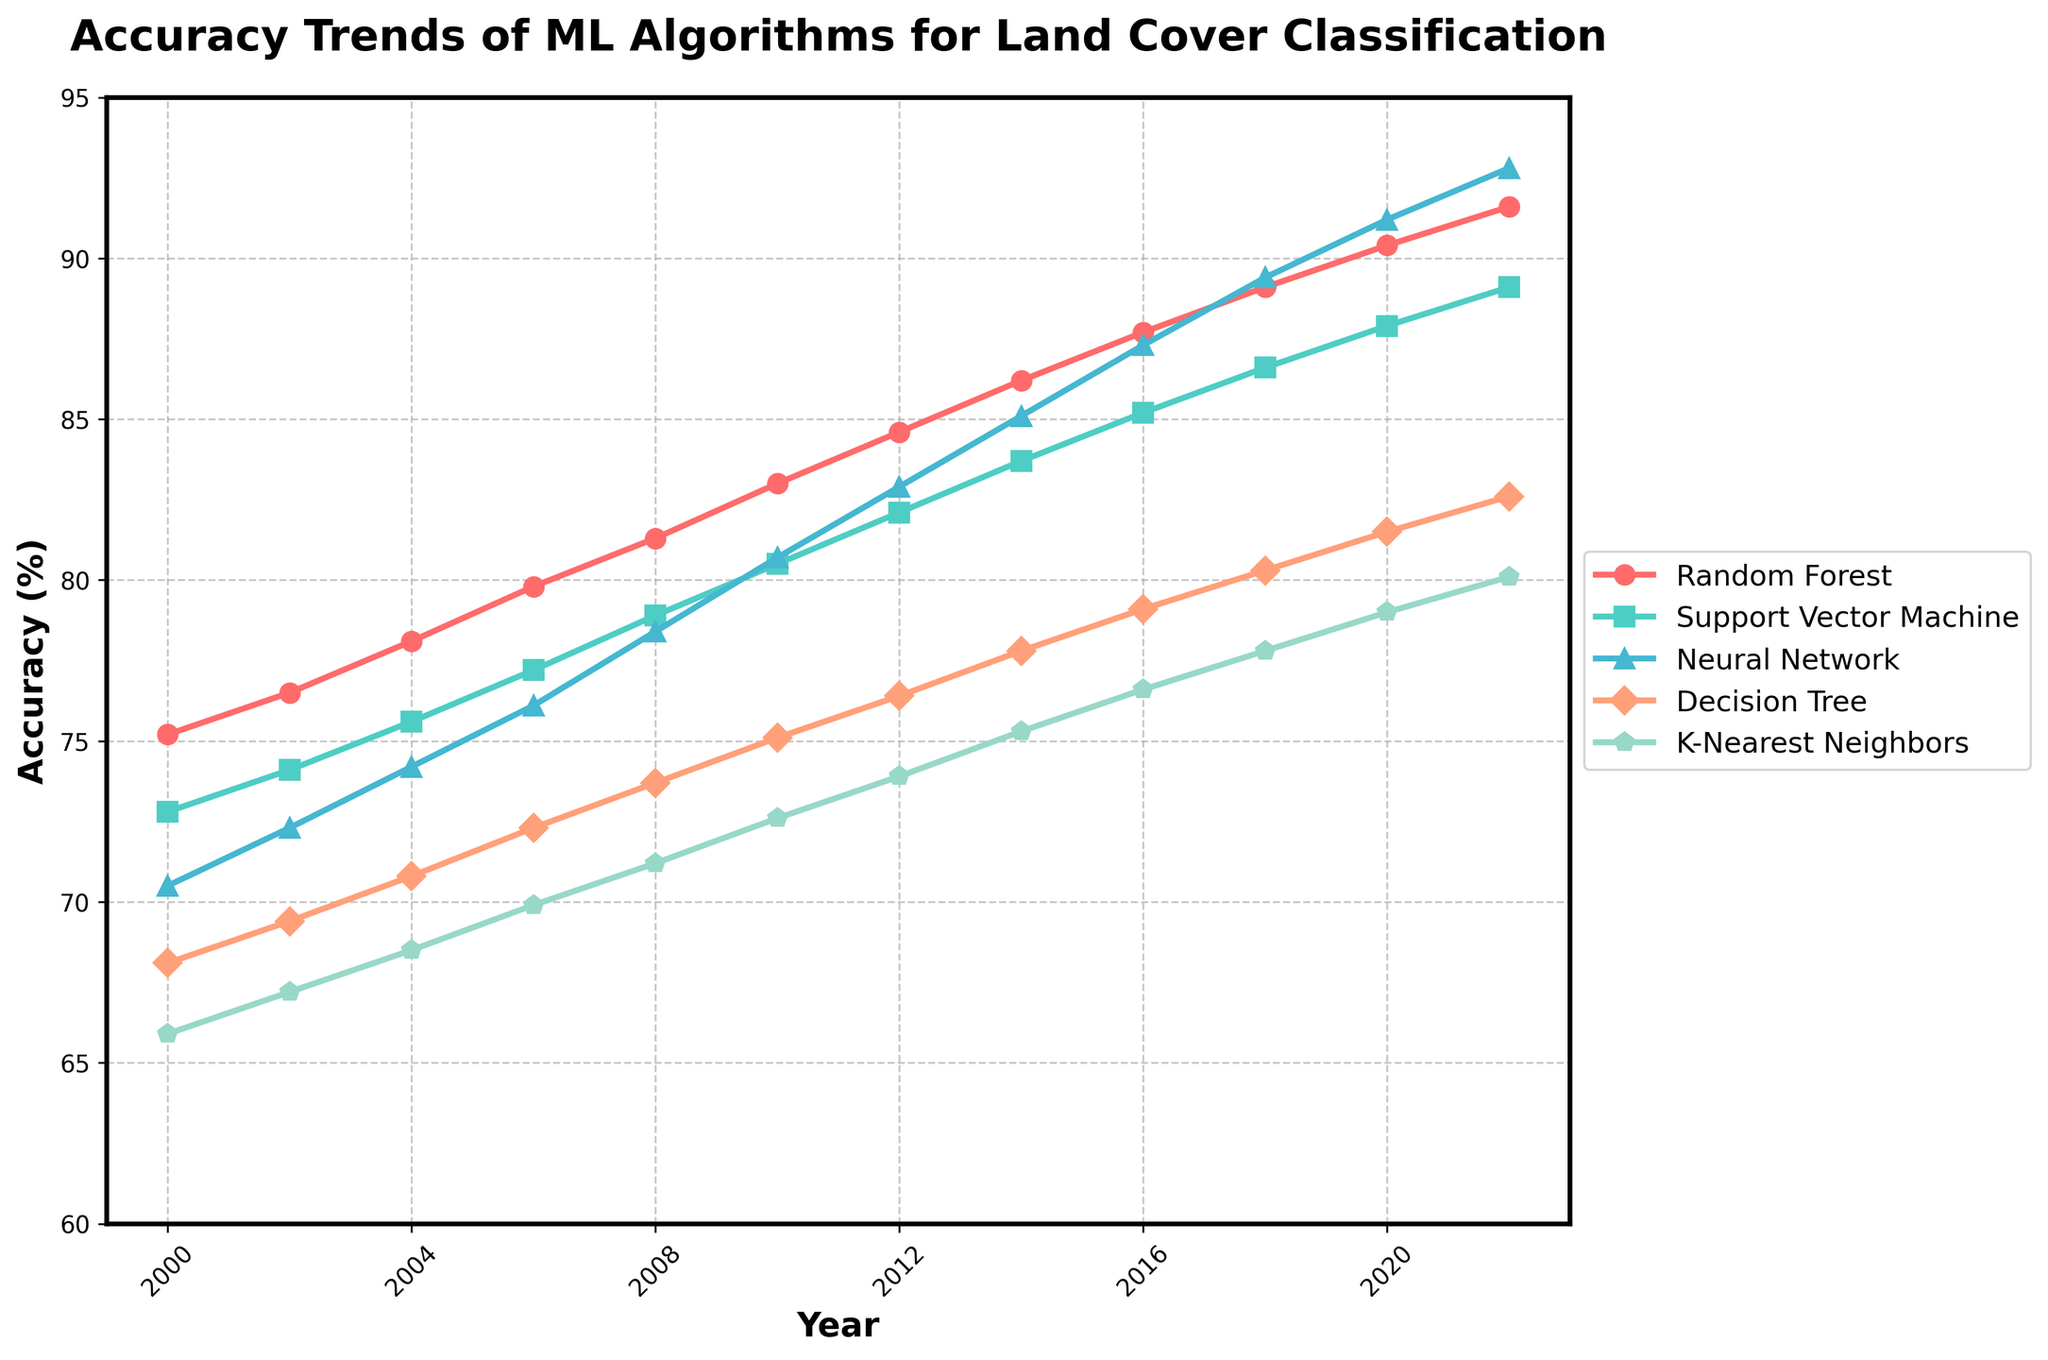Which machine learning algorithm shows the highest accuracy in 2022? Looking at the endpoint of each line in the year 2022, the Neural Network line is at the highest position on the y-axis.
Answer: Neural Network What’s the average accuracy of the Random Forest algorithm over the entire period? Sum all the accuracy values for Random Forest (75.2 + 76.5 + 78.1 + 79.8 + 81.3 + 83.0 + 84.6 + 86.2 + 87.7 + 89.1 + 90.4 + 91.6) = 1003.5, then divide by the number of years (12). 1003.5 / 12 = 83.625.
Answer: 83.625 Which algorithm has shown the least improvement in accuracy from 2000 to 2022? Calculate the improvement for each algorithm by subtracting the accuracy in 2000 from the accuracy in 2022. The smallest difference indicates the least improvement. Improvement: Random Forest: 91.6 - 75.2 = 16.4, Support Vector Machine: 89.1 - 72.8 = 16.3, Neural Network: 92.8 - 70.5 = 22.3, Decision Tree: 82.6 - 68.1 = 14.5, K-Nearest Neighbors: 80.1 - 65.9 = 14.2. The smallest improvement is for K-Nearest Neighbors.
Answer: K-Nearest Neighbors Between which consecutive years did Support Vector Machine show the largest increase in accuracy? Look at the increase in accuracy for Support Vector Machine between consecutive years and find the largest difference: 2000-2002: 74.1 - 72.8 = 1.3, 2002-2004: 75.6 - 74.1 = 1.5, 2004-2006: 77.2 - 75.6 = 1.6, 2006-2008: 78.9 - 77.2 = 1.7, 2008-2010: 80.5 - 78.9 = 1.6, 2010-2012: 82.1 - 80.5 = 1.6, 2012-2014: 83.7 - 82.1 = 1.6, 2014-2016: 85.2 - 83.7 = 1.5, 2016-2018: 86.6 - 85.2 = 1.4, 2018-2020: 87.9 - 86.6 = 1.3, 2020-2022: 89.1 - 87.9 = 1.2. The largest increase is from 2006 to 2008.
Answer: 2006-2008 What is the difference in accuracy between Random Forest and Decision Tree in 2010? Find the accuracy values for both algorithms in 2010: Random Forest: 83.0, Decision Tree: 75.1. Calculate the difference: 83.0 - 75.1 = 7.9.
Answer: 7.9 How many algorithms reached an accuracy of at least 80% in 2014? Check the accuracy values for all algorithms in 2014. Random Forest: 86.2, Support Vector Machine: 83.7, Neural Network: 85.1, Decision Tree: 77.8, K-Nearest Neighbors: 75.3. Three algorithms (Random Forest, Support Vector Machine, Neural Network) have accuracy greater than or equal to 80%.
Answer: 3 